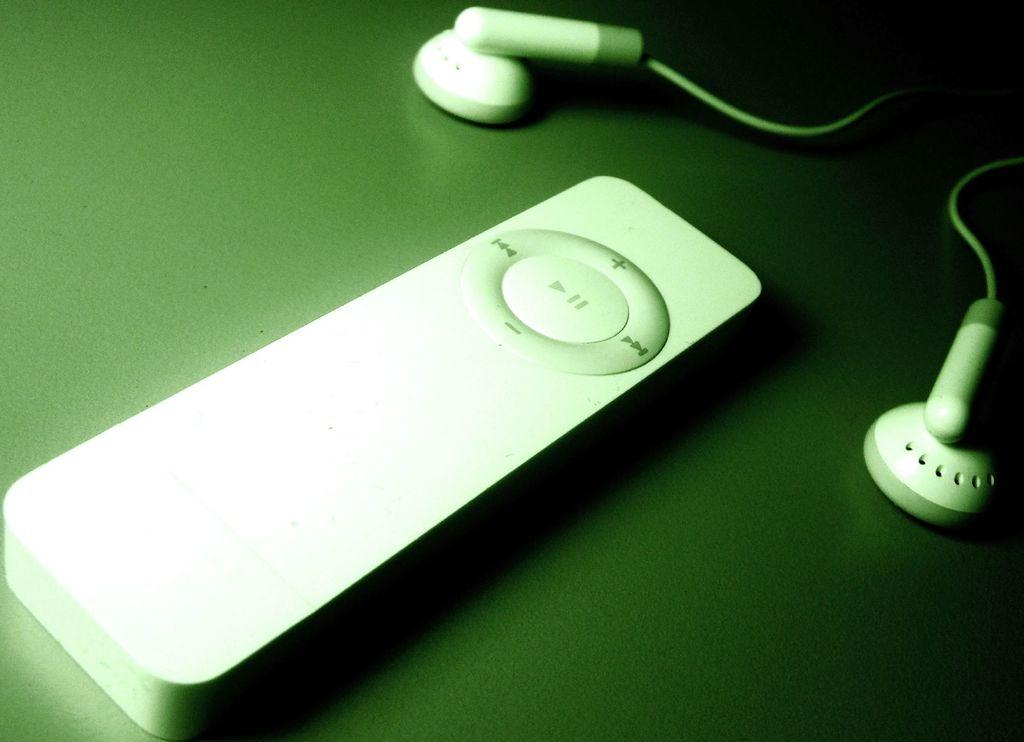What is the main object in the center of the image? There is a small music player in the middle of the image. What might be used to listen to the music from the player? There are headphones beside the music player. How many oranges are on the music player in the image? There are no oranges present in the image; it only features a music player and headphones. 